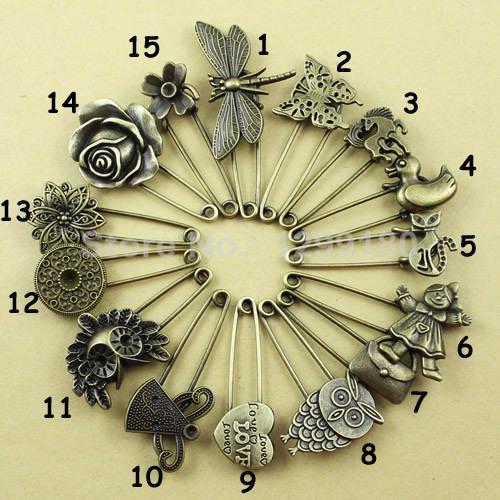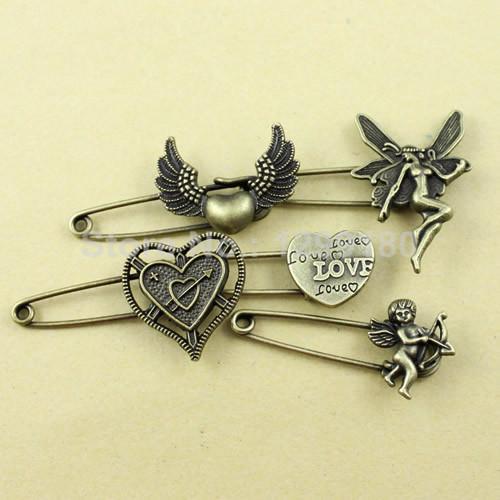The first image is the image on the left, the second image is the image on the right. Given the left and right images, does the statement "An image shows pins arranged like spokes forming a circle." hold true? Answer yes or no. Yes. 